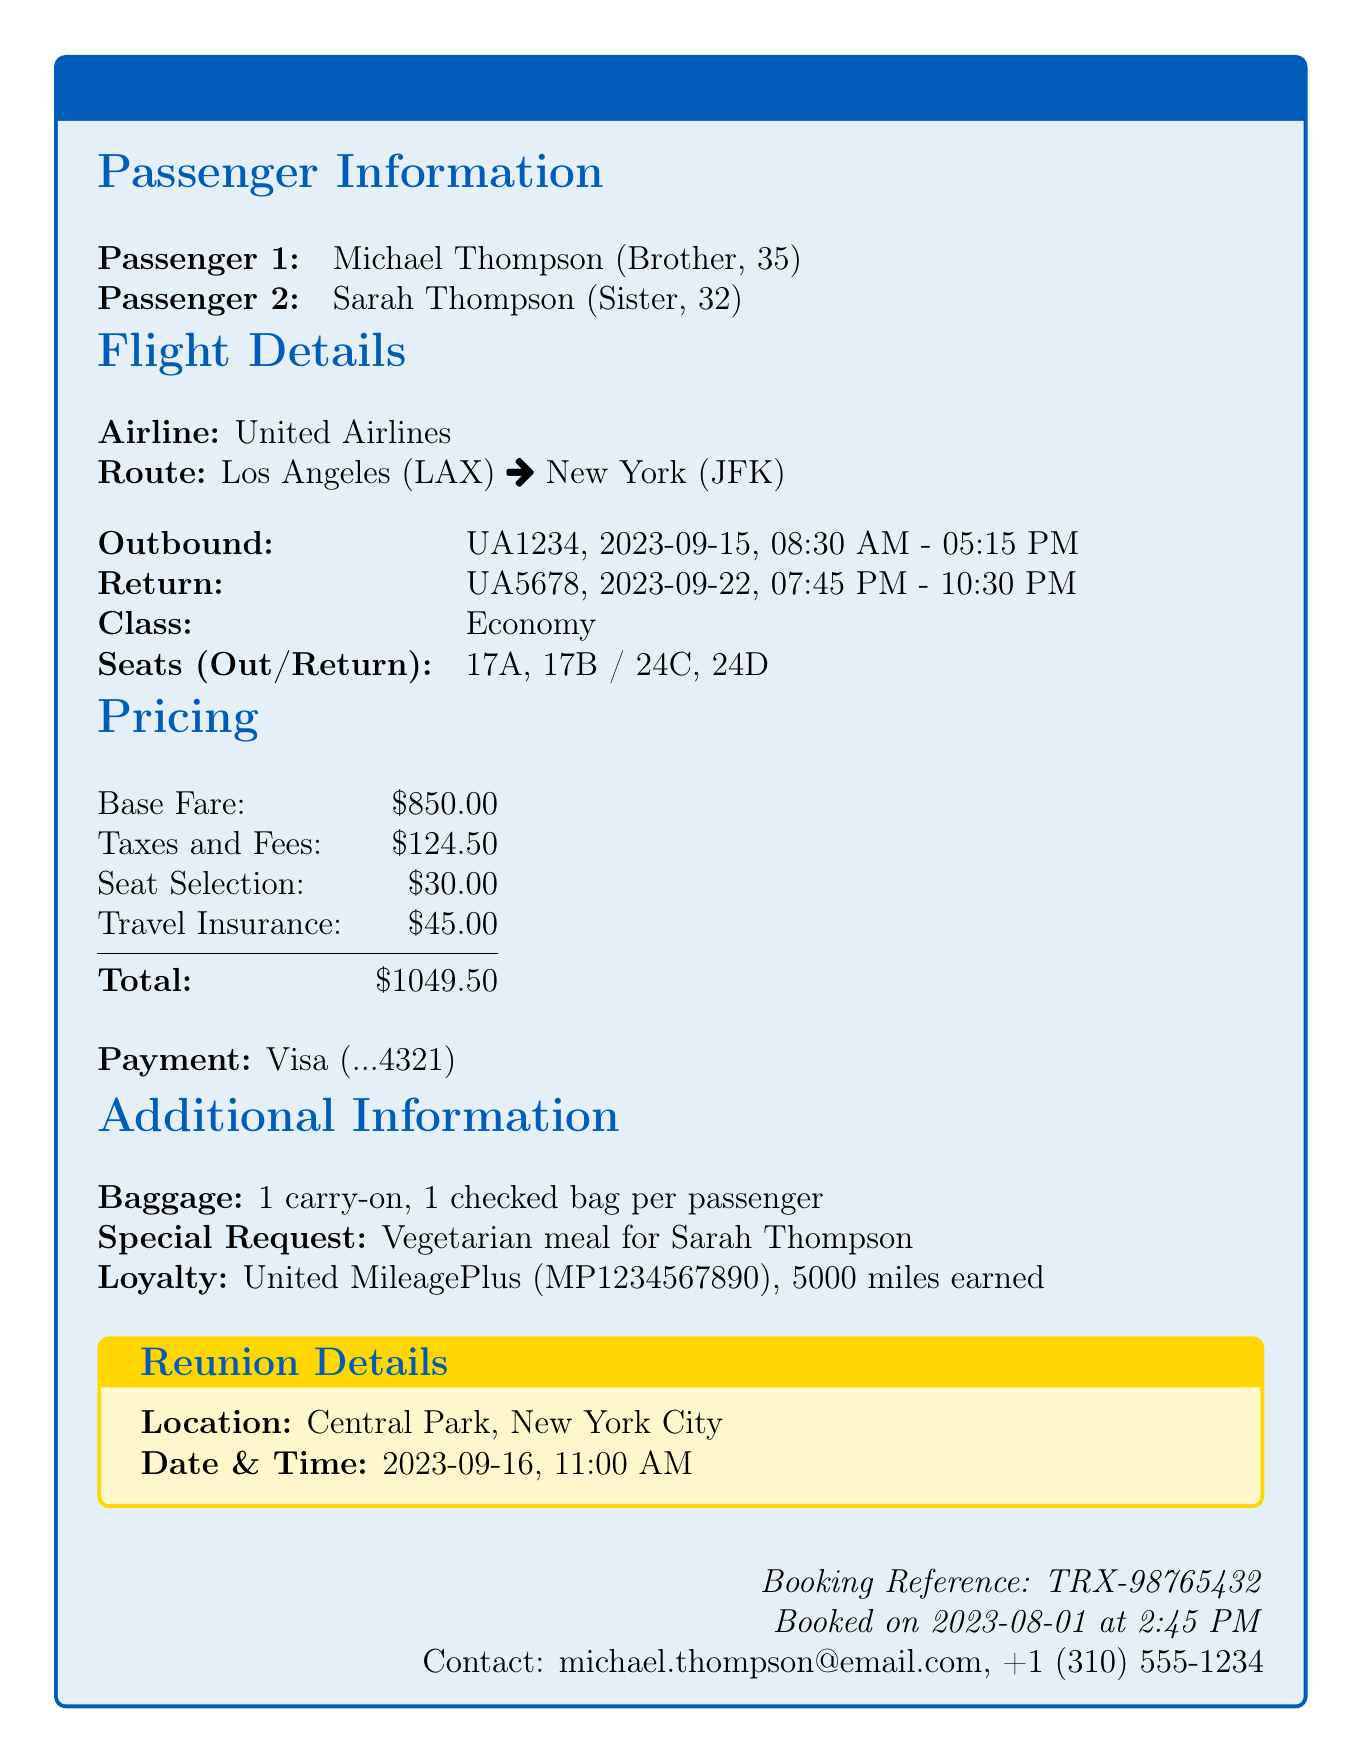what is the transaction ID? The transaction ID is depicted in the document as a unique identifier for the transaction, which is TRX-98765432.
Answer: TRX-98765432 who are the passengers? The document lists the passengers along with their relationships, which are Michael Thompson (Brother) and Sarah Thompson (Sister).
Answer: Michael Thompson, Sarah Thompson what is the departure airport? The airport from which the flight departs is indicated in the document as Los Angeles International Airport (LAX).
Answer: Los Angeles International Airport (LAX) when is the reunion? The document specifies the date and time of the reunion meeting as 2023-09-16 at 11:00 AM.
Answer: 2023-09-16, 11:00 AM how many miles will Michael earn? The loyalty program section states that Michael Thompson will earn 5000 miles from this transaction.
Answer: 5000 what is the total price of the tickets? The total price includes the base fare, taxes, and other fees, which sums up to $1004.50 in the document.
Answer: $1004.50 what is the special request made in the booking? The document mentions a special request for a vegetarian meal for Sarah Thompson during the flight.
Answer: Vegetarian meal for Sarah Thompson what class are the tickets purchased in? The ticket class information provided in the document indicates that the tickets were purchased in Economy class.
Answer: Economy how many checked bags are allowed? The document mentions the baggage allowance, which allows for one checked bag per passenger.
Answer: 1 checked bag per passenger 